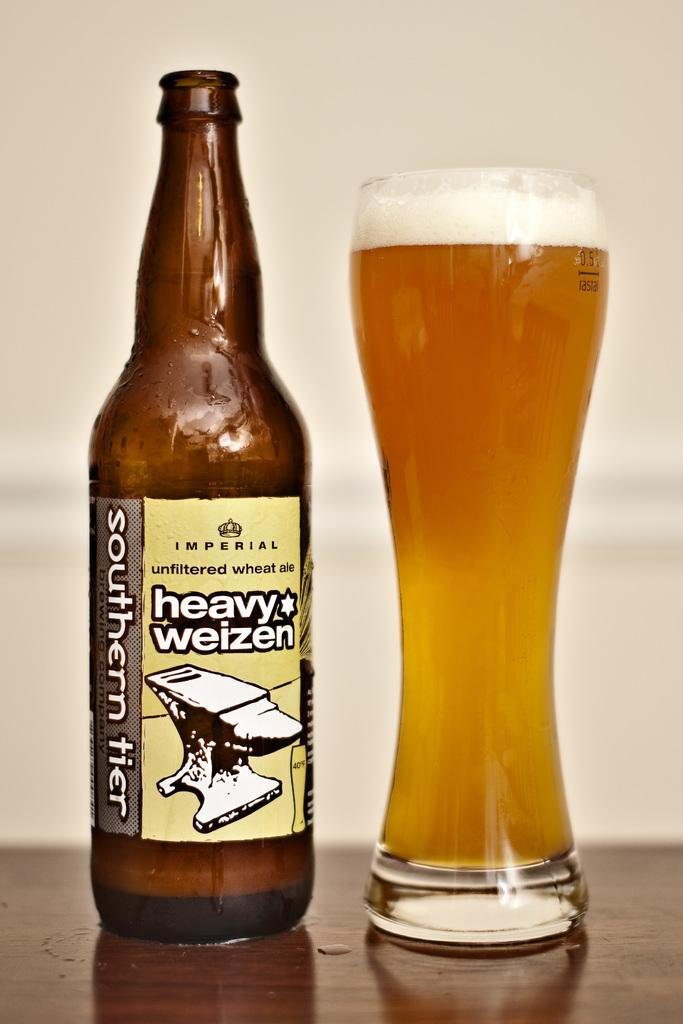<image>
Relay a brief, clear account of the picture shown. a bottle of heavy weizen beer site beside a tall glass of beer 